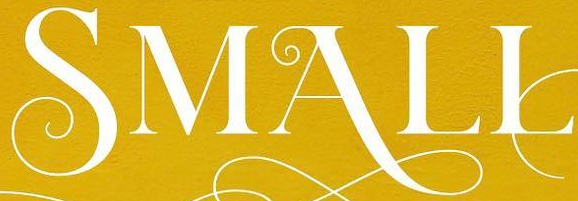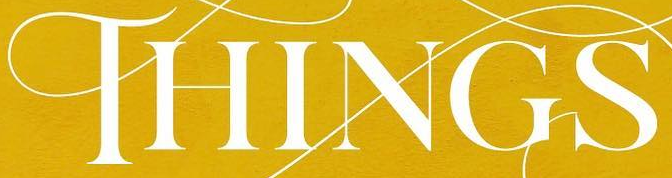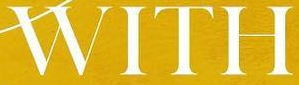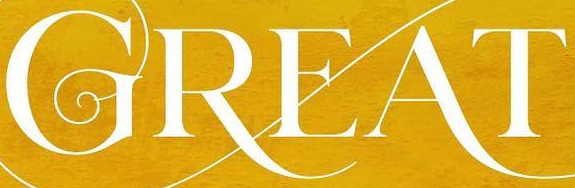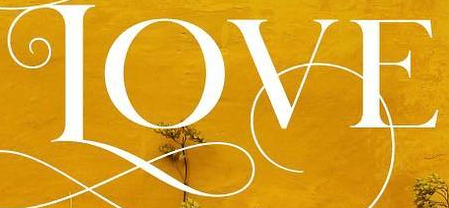Identify the words shown in these images in order, separated by a semicolon. SMALL; THINGS; WITH; GREAT; LOVE 